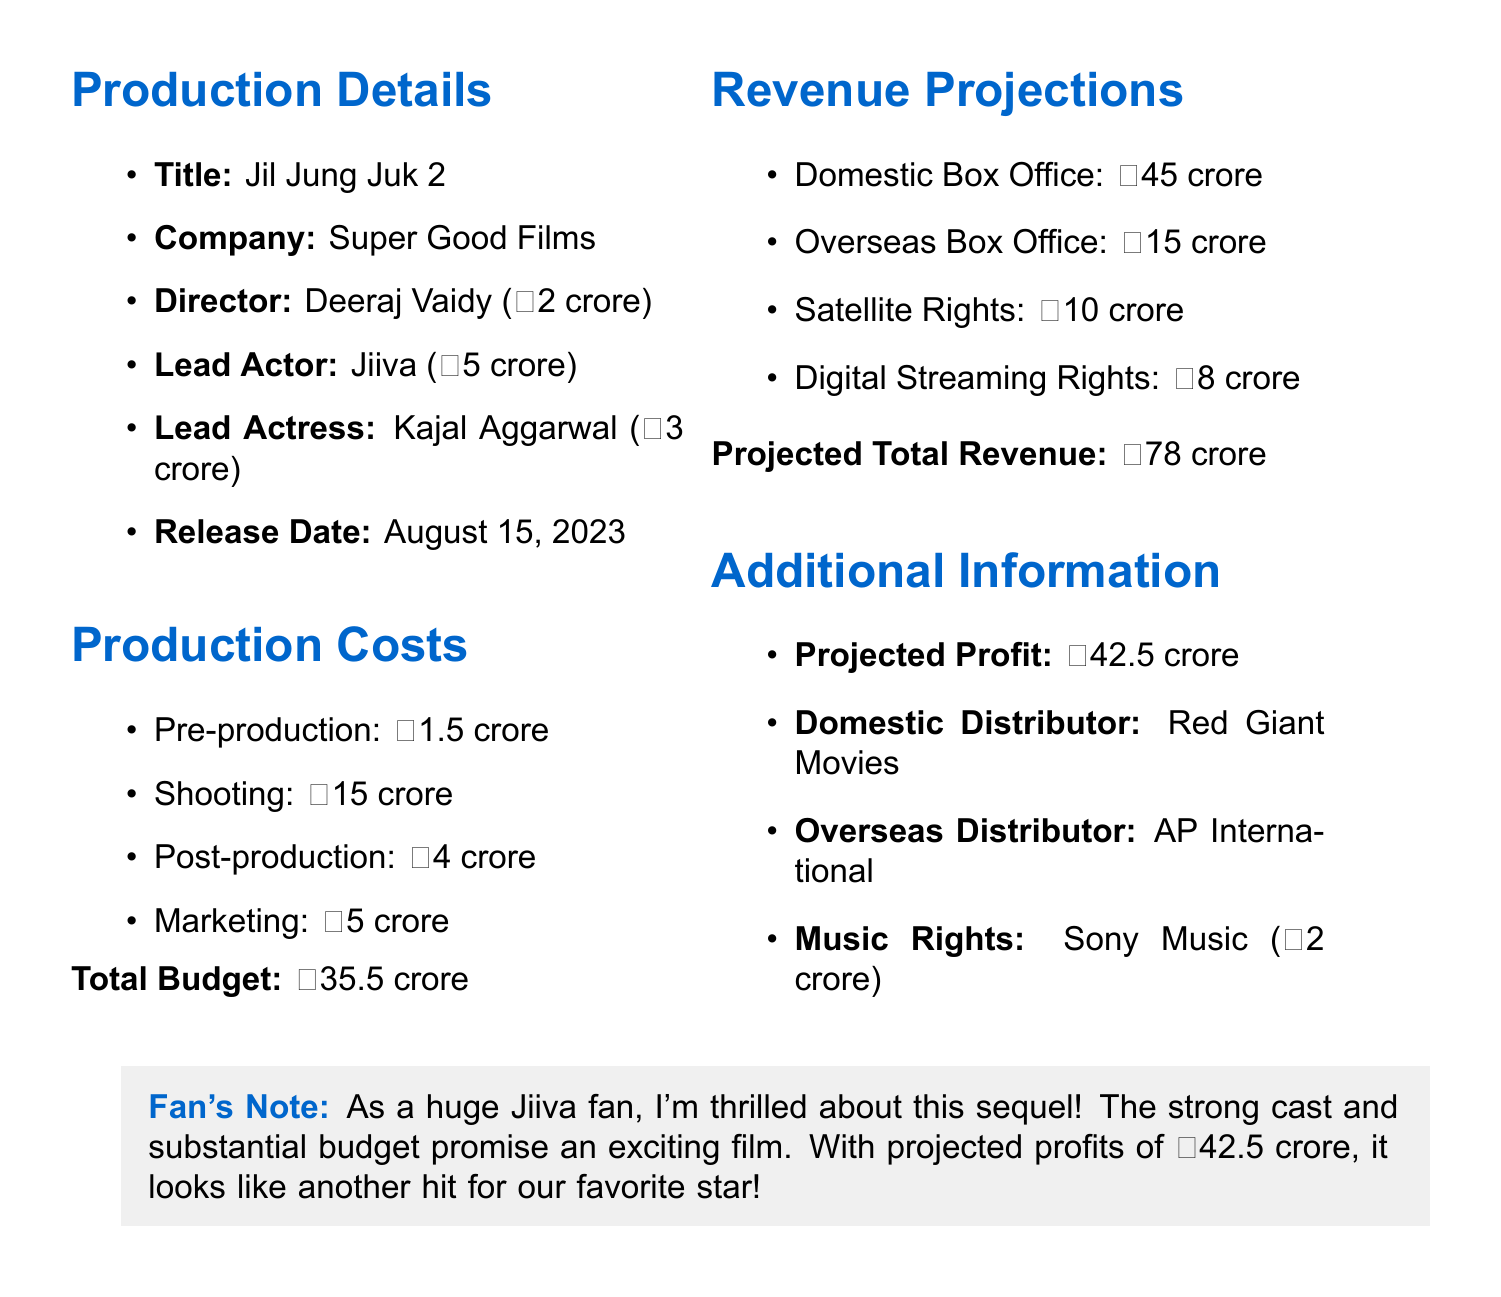What is the production title? The production title is explicitly mentioned in the document.
Answer: Jil Jung Juk 2 Who is the lead actor? The document lists the cast, naming Jiiva as the lead actor.
Answer: Jiiva What is the director's fee? The fee for the director is provided directly in the document.
Answer: ₹2 crore What is the total budget? The total budget is called out in the production costs section of the document.
Answer: ₹35.5 crore What are the domestic revenue projections? The document specifies the expected domestic box office revenue.
Answer: ₹45 crore Calculate the projected profit. The projected profit is stated clearly in the document by subtracting total costs from total revenue.
Answer: ₹42.5 crore What company holds the music rights? The document mentions the company owning the music rights.
Answer: Sony Music Who is the domestic distributor? The document explicitly states the name of the domestic distributor.
Answer: Red Giant Movies What is the release date of the film? The release date is included under production details in the document.
Answer: August 15, 2023 